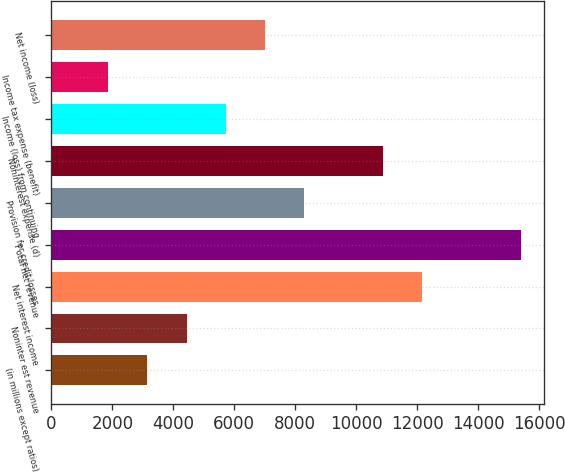Convert chart. <chart><loc_0><loc_0><loc_500><loc_500><bar_chart><fcel>(in millions except ratios)<fcel>Noninter est revenue<fcel>Net interest income<fcel>T otal net revenue<fcel>Provision for credit losses<fcel>Noninterest expense (d)<fcel>Income (loss) from continuing<fcel>Income tax expense (benefit)<fcel>Net income (loss)<nl><fcel>3144<fcel>4433<fcel>12167<fcel>15389<fcel>8300<fcel>10878<fcel>5722<fcel>1855<fcel>7011<nl></chart> 